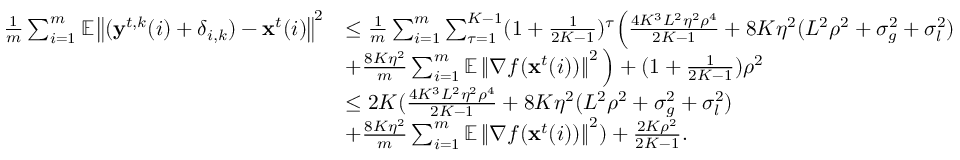<formula> <loc_0><loc_0><loc_500><loc_500>\begin{array} { r l } { \frac { 1 } { m } \sum _ { i = 1 } ^ { m } \mathbb { E } \left \| ( y ^ { t , k } ( i ) + \delta _ { i , k } ) - x ^ { t } ( i ) \right \| ^ { 2 } } & { \leq \frac { 1 } { m } \sum _ { i = 1 } ^ { m } \sum _ { \tau = 1 } ^ { K - 1 } ( 1 + \frac { 1 } { 2 K - 1 } ) ^ { \tau } \left ( \frac { 4 K ^ { 3 } L ^ { 2 } \eta ^ { 2 } \rho ^ { 4 } } { 2 K - 1 } + 8 K \eta ^ { 2 } ( L ^ { 2 } \rho ^ { 2 } + \sigma _ { g } ^ { 2 } + \sigma _ { l } ^ { 2 } ) } \\ & { + \frac { 8 K \eta ^ { 2 } } { m } \sum _ { i = 1 } ^ { m } \mathbb { E } \left \| \nabla f ( x ^ { t } ( i ) ) \right \| ^ { 2 } \right ) + ( 1 + \frac { 1 } { 2 K - 1 } ) \rho ^ { 2 } } \\ & { \leq 2 K ( \frac { 4 K ^ { 3 } L ^ { 2 } \eta ^ { 2 } \rho ^ { 4 } } { 2 K - 1 } + 8 K \eta ^ { 2 } ( L ^ { 2 } \rho ^ { 2 } + \sigma _ { g } ^ { 2 } + \sigma _ { l } ^ { 2 } ) } \\ & { + \frac { 8 K \eta ^ { 2 } } { m } \sum _ { i = 1 } ^ { m } \mathbb { E } \left \| \nabla f ( x ^ { t } ( i ) ) \right \| ^ { 2 } ) + \frac { 2 K \rho ^ { 2 } } { 2 K - 1 } . } \end{array}</formula> 